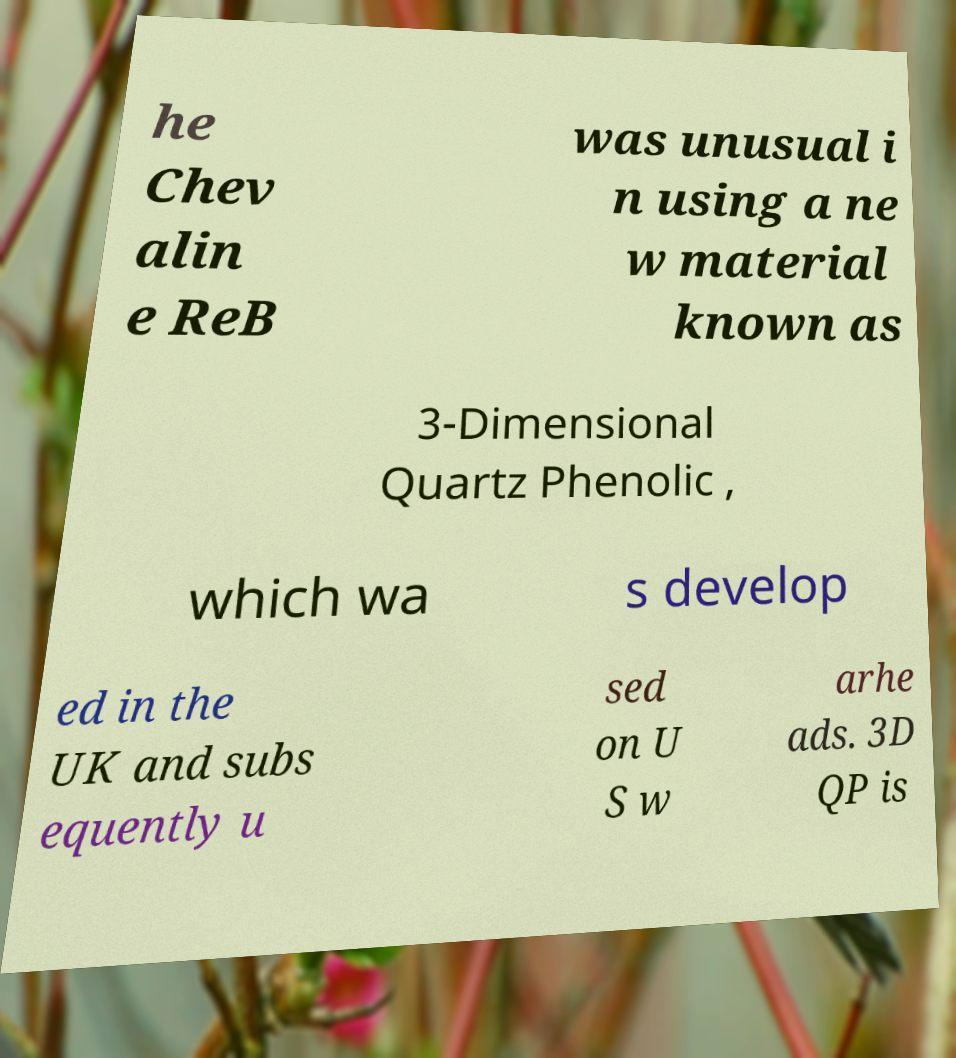Could you assist in decoding the text presented in this image and type it out clearly? he Chev alin e ReB was unusual i n using a ne w material known as 3-Dimensional Quartz Phenolic , which wa s develop ed in the UK and subs equently u sed on U S w arhe ads. 3D QP is 